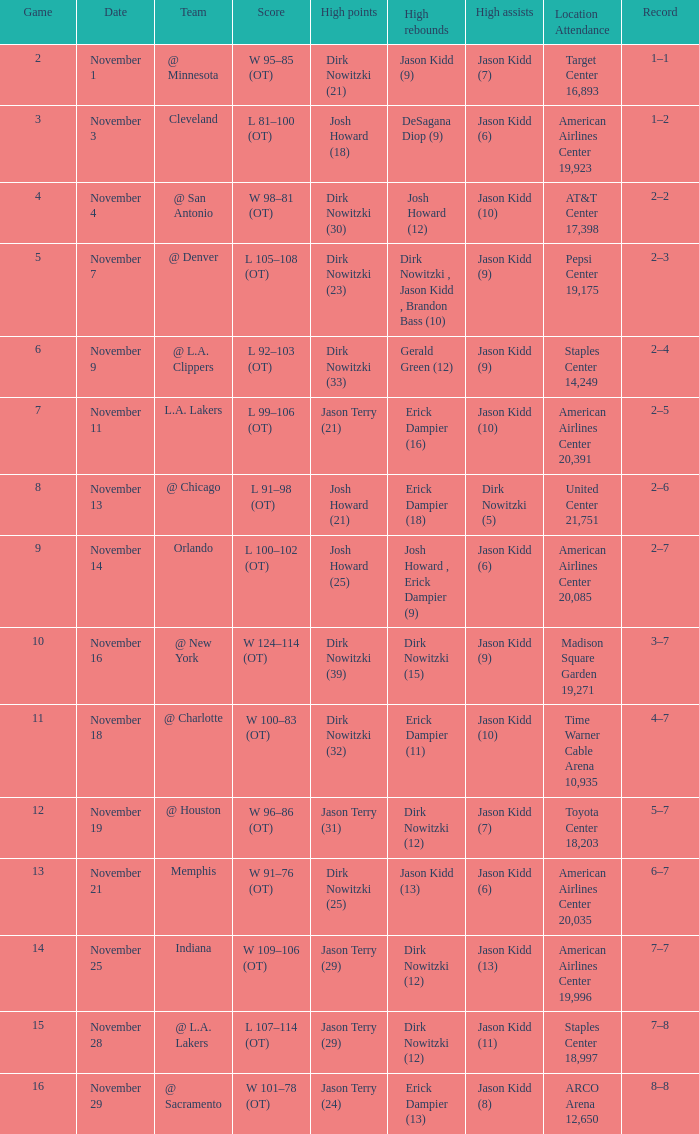What is High Rebounds, when High Assists is "Jason Kidd (13)"? Dirk Nowitzki (12). Help me parse the entirety of this table. {'header': ['Game', 'Date', 'Team', 'Score', 'High points', 'High rebounds', 'High assists', 'Location Attendance', 'Record'], 'rows': [['2', 'November 1', '@ Minnesota', 'W 95–85 (OT)', 'Dirk Nowitzki (21)', 'Jason Kidd (9)', 'Jason Kidd (7)', 'Target Center 16,893', '1–1'], ['3', 'November 3', 'Cleveland', 'L 81–100 (OT)', 'Josh Howard (18)', 'DeSagana Diop (9)', 'Jason Kidd (6)', 'American Airlines Center 19,923', '1–2'], ['4', 'November 4', '@ San Antonio', 'W 98–81 (OT)', 'Dirk Nowitzki (30)', 'Josh Howard (12)', 'Jason Kidd (10)', 'AT&T Center 17,398', '2–2'], ['5', 'November 7', '@ Denver', 'L 105–108 (OT)', 'Dirk Nowitzki (23)', 'Dirk Nowitzki , Jason Kidd , Brandon Bass (10)', 'Jason Kidd (9)', 'Pepsi Center 19,175', '2–3'], ['6', 'November 9', '@ L.A. Clippers', 'L 92–103 (OT)', 'Dirk Nowitzki (33)', 'Gerald Green (12)', 'Jason Kidd (9)', 'Staples Center 14,249', '2–4'], ['7', 'November 11', 'L.A. Lakers', 'L 99–106 (OT)', 'Jason Terry (21)', 'Erick Dampier (16)', 'Jason Kidd (10)', 'American Airlines Center 20,391', '2–5'], ['8', 'November 13', '@ Chicago', 'L 91–98 (OT)', 'Josh Howard (21)', 'Erick Dampier (18)', 'Dirk Nowitzki (5)', 'United Center 21,751', '2–6'], ['9', 'November 14', 'Orlando', 'L 100–102 (OT)', 'Josh Howard (25)', 'Josh Howard , Erick Dampier (9)', 'Jason Kidd (6)', 'American Airlines Center 20,085', '2–7'], ['10', 'November 16', '@ New York', 'W 124–114 (OT)', 'Dirk Nowitzki (39)', 'Dirk Nowitzki (15)', 'Jason Kidd (9)', 'Madison Square Garden 19,271', '3–7'], ['11', 'November 18', '@ Charlotte', 'W 100–83 (OT)', 'Dirk Nowitzki (32)', 'Erick Dampier (11)', 'Jason Kidd (10)', 'Time Warner Cable Arena 10,935', '4–7'], ['12', 'November 19', '@ Houston', 'W 96–86 (OT)', 'Jason Terry (31)', 'Dirk Nowitzki (12)', 'Jason Kidd (7)', 'Toyota Center 18,203', '5–7'], ['13', 'November 21', 'Memphis', 'W 91–76 (OT)', 'Dirk Nowitzki (25)', 'Jason Kidd (13)', 'Jason Kidd (6)', 'American Airlines Center 20,035', '6–7'], ['14', 'November 25', 'Indiana', 'W 109–106 (OT)', 'Jason Terry (29)', 'Dirk Nowitzki (12)', 'Jason Kidd (13)', 'American Airlines Center 19,996', '7–7'], ['15', 'November 28', '@ L.A. Lakers', 'L 107–114 (OT)', 'Jason Terry (29)', 'Dirk Nowitzki (12)', 'Jason Kidd (11)', 'Staples Center 18,997', '7–8'], ['16', 'November 29', '@ Sacramento', 'W 101–78 (OT)', 'Jason Terry (24)', 'Erick Dampier (13)', 'Jason Kidd (8)', 'ARCO Arena 12,650', '8–8']]} 